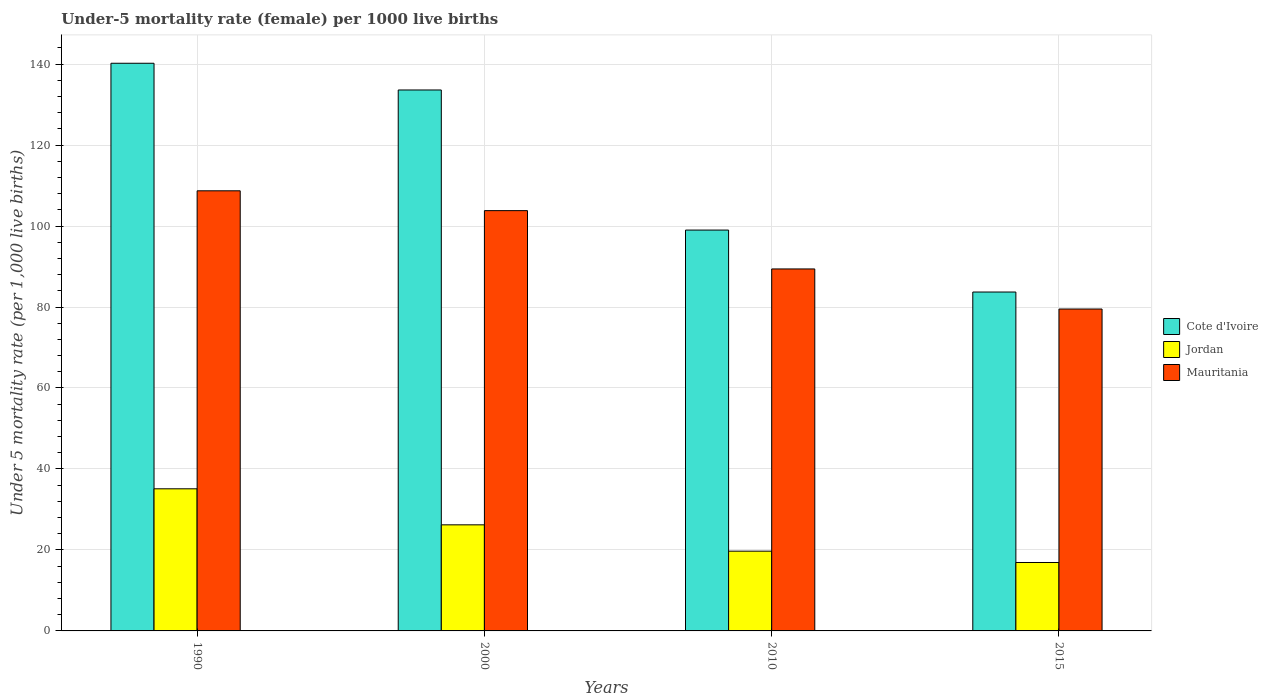How many different coloured bars are there?
Your answer should be very brief. 3. Are the number of bars on each tick of the X-axis equal?
Offer a terse response. Yes. How many bars are there on the 1st tick from the right?
Your answer should be very brief. 3. What is the label of the 1st group of bars from the left?
Make the answer very short. 1990. What is the under-five mortality rate in Cote d'Ivoire in 2010?
Make the answer very short. 99. Across all years, what is the maximum under-five mortality rate in Jordan?
Ensure brevity in your answer.  35.1. Across all years, what is the minimum under-five mortality rate in Mauritania?
Make the answer very short. 79.5. In which year was the under-five mortality rate in Jordan minimum?
Provide a succinct answer. 2015. What is the total under-five mortality rate in Jordan in the graph?
Provide a succinct answer. 97.9. What is the difference between the under-five mortality rate in Cote d'Ivoire in 2000 and that in 2015?
Provide a short and direct response. 49.9. What is the difference between the under-five mortality rate in Cote d'Ivoire in 2000 and the under-five mortality rate in Jordan in 2010?
Offer a terse response. 113.9. What is the average under-five mortality rate in Mauritania per year?
Your response must be concise. 95.35. In the year 2000, what is the difference between the under-five mortality rate in Mauritania and under-five mortality rate in Cote d'Ivoire?
Provide a short and direct response. -29.8. What is the ratio of the under-five mortality rate in Cote d'Ivoire in 2010 to that in 2015?
Ensure brevity in your answer.  1.18. Is the under-five mortality rate in Jordan in 1990 less than that in 2010?
Your answer should be very brief. No. Is the difference between the under-five mortality rate in Mauritania in 2010 and 2015 greater than the difference between the under-five mortality rate in Cote d'Ivoire in 2010 and 2015?
Your response must be concise. No. What is the difference between the highest and the second highest under-five mortality rate in Mauritania?
Offer a terse response. 4.9. What is the difference between the highest and the lowest under-five mortality rate in Mauritania?
Provide a short and direct response. 29.2. What does the 3rd bar from the left in 2015 represents?
Keep it short and to the point. Mauritania. What does the 1st bar from the right in 2010 represents?
Make the answer very short. Mauritania. Is it the case that in every year, the sum of the under-five mortality rate in Mauritania and under-five mortality rate in Jordan is greater than the under-five mortality rate in Cote d'Ivoire?
Provide a short and direct response. No. How many bars are there?
Provide a short and direct response. 12. Are all the bars in the graph horizontal?
Keep it short and to the point. No. How many years are there in the graph?
Your answer should be compact. 4. What is the difference between two consecutive major ticks on the Y-axis?
Provide a short and direct response. 20. Are the values on the major ticks of Y-axis written in scientific E-notation?
Your answer should be compact. No. Where does the legend appear in the graph?
Your answer should be very brief. Center right. How many legend labels are there?
Ensure brevity in your answer.  3. What is the title of the graph?
Provide a succinct answer. Under-5 mortality rate (female) per 1000 live births. What is the label or title of the Y-axis?
Provide a succinct answer. Under 5 mortality rate (per 1,0 live births). What is the Under 5 mortality rate (per 1,000 live births) in Cote d'Ivoire in 1990?
Provide a succinct answer. 140.2. What is the Under 5 mortality rate (per 1,000 live births) in Jordan in 1990?
Keep it short and to the point. 35.1. What is the Under 5 mortality rate (per 1,000 live births) in Mauritania in 1990?
Provide a succinct answer. 108.7. What is the Under 5 mortality rate (per 1,000 live births) in Cote d'Ivoire in 2000?
Ensure brevity in your answer.  133.6. What is the Under 5 mortality rate (per 1,000 live births) of Jordan in 2000?
Make the answer very short. 26.2. What is the Under 5 mortality rate (per 1,000 live births) in Mauritania in 2000?
Your response must be concise. 103.8. What is the Under 5 mortality rate (per 1,000 live births) of Cote d'Ivoire in 2010?
Give a very brief answer. 99. What is the Under 5 mortality rate (per 1,000 live births) in Jordan in 2010?
Your answer should be compact. 19.7. What is the Under 5 mortality rate (per 1,000 live births) in Mauritania in 2010?
Your answer should be compact. 89.4. What is the Under 5 mortality rate (per 1,000 live births) of Cote d'Ivoire in 2015?
Provide a succinct answer. 83.7. What is the Under 5 mortality rate (per 1,000 live births) in Mauritania in 2015?
Provide a short and direct response. 79.5. Across all years, what is the maximum Under 5 mortality rate (per 1,000 live births) in Cote d'Ivoire?
Offer a terse response. 140.2. Across all years, what is the maximum Under 5 mortality rate (per 1,000 live births) of Jordan?
Keep it short and to the point. 35.1. Across all years, what is the maximum Under 5 mortality rate (per 1,000 live births) in Mauritania?
Your answer should be compact. 108.7. Across all years, what is the minimum Under 5 mortality rate (per 1,000 live births) in Cote d'Ivoire?
Provide a short and direct response. 83.7. Across all years, what is the minimum Under 5 mortality rate (per 1,000 live births) in Jordan?
Provide a short and direct response. 16.9. Across all years, what is the minimum Under 5 mortality rate (per 1,000 live births) in Mauritania?
Your answer should be compact. 79.5. What is the total Under 5 mortality rate (per 1,000 live births) of Cote d'Ivoire in the graph?
Provide a short and direct response. 456.5. What is the total Under 5 mortality rate (per 1,000 live births) of Jordan in the graph?
Your answer should be very brief. 97.9. What is the total Under 5 mortality rate (per 1,000 live births) of Mauritania in the graph?
Give a very brief answer. 381.4. What is the difference between the Under 5 mortality rate (per 1,000 live births) in Mauritania in 1990 and that in 2000?
Make the answer very short. 4.9. What is the difference between the Under 5 mortality rate (per 1,000 live births) of Cote d'Ivoire in 1990 and that in 2010?
Keep it short and to the point. 41.2. What is the difference between the Under 5 mortality rate (per 1,000 live births) of Jordan in 1990 and that in 2010?
Your answer should be very brief. 15.4. What is the difference between the Under 5 mortality rate (per 1,000 live births) in Mauritania in 1990 and that in 2010?
Give a very brief answer. 19.3. What is the difference between the Under 5 mortality rate (per 1,000 live births) of Cote d'Ivoire in 1990 and that in 2015?
Make the answer very short. 56.5. What is the difference between the Under 5 mortality rate (per 1,000 live births) of Mauritania in 1990 and that in 2015?
Your answer should be very brief. 29.2. What is the difference between the Under 5 mortality rate (per 1,000 live births) in Cote d'Ivoire in 2000 and that in 2010?
Your answer should be compact. 34.6. What is the difference between the Under 5 mortality rate (per 1,000 live births) in Mauritania in 2000 and that in 2010?
Offer a terse response. 14.4. What is the difference between the Under 5 mortality rate (per 1,000 live births) of Cote d'Ivoire in 2000 and that in 2015?
Keep it short and to the point. 49.9. What is the difference between the Under 5 mortality rate (per 1,000 live births) of Jordan in 2000 and that in 2015?
Offer a terse response. 9.3. What is the difference between the Under 5 mortality rate (per 1,000 live births) of Mauritania in 2000 and that in 2015?
Offer a very short reply. 24.3. What is the difference between the Under 5 mortality rate (per 1,000 live births) in Cote d'Ivoire in 2010 and that in 2015?
Ensure brevity in your answer.  15.3. What is the difference between the Under 5 mortality rate (per 1,000 live births) in Jordan in 2010 and that in 2015?
Keep it short and to the point. 2.8. What is the difference between the Under 5 mortality rate (per 1,000 live births) of Cote d'Ivoire in 1990 and the Under 5 mortality rate (per 1,000 live births) of Jordan in 2000?
Offer a terse response. 114. What is the difference between the Under 5 mortality rate (per 1,000 live births) of Cote d'Ivoire in 1990 and the Under 5 mortality rate (per 1,000 live births) of Mauritania in 2000?
Your response must be concise. 36.4. What is the difference between the Under 5 mortality rate (per 1,000 live births) in Jordan in 1990 and the Under 5 mortality rate (per 1,000 live births) in Mauritania in 2000?
Offer a very short reply. -68.7. What is the difference between the Under 5 mortality rate (per 1,000 live births) of Cote d'Ivoire in 1990 and the Under 5 mortality rate (per 1,000 live births) of Jordan in 2010?
Provide a succinct answer. 120.5. What is the difference between the Under 5 mortality rate (per 1,000 live births) in Cote d'Ivoire in 1990 and the Under 5 mortality rate (per 1,000 live births) in Mauritania in 2010?
Offer a terse response. 50.8. What is the difference between the Under 5 mortality rate (per 1,000 live births) of Jordan in 1990 and the Under 5 mortality rate (per 1,000 live births) of Mauritania in 2010?
Offer a terse response. -54.3. What is the difference between the Under 5 mortality rate (per 1,000 live births) of Cote d'Ivoire in 1990 and the Under 5 mortality rate (per 1,000 live births) of Jordan in 2015?
Provide a succinct answer. 123.3. What is the difference between the Under 5 mortality rate (per 1,000 live births) in Cote d'Ivoire in 1990 and the Under 5 mortality rate (per 1,000 live births) in Mauritania in 2015?
Ensure brevity in your answer.  60.7. What is the difference between the Under 5 mortality rate (per 1,000 live births) of Jordan in 1990 and the Under 5 mortality rate (per 1,000 live births) of Mauritania in 2015?
Make the answer very short. -44.4. What is the difference between the Under 5 mortality rate (per 1,000 live births) in Cote d'Ivoire in 2000 and the Under 5 mortality rate (per 1,000 live births) in Jordan in 2010?
Provide a succinct answer. 113.9. What is the difference between the Under 5 mortality rate (per 1,000 live births) in Cote d'Ivoire in 2000 and the Under 5 mortality rate (per 1,000 live births) in Mauritania in 2010?
Offer a terse response. 44.2. What is the difference between the Under 5 mortality rate (per 1,000 live births) of Jordan in 2000 and the Under 5 mortality rate (per 1,000 live births) of Mauritania in 2010?
Keep it short and to the point. -63.2. What is the difference between the Under 5 mortality rate (per 1,000 live births) in Cote d'Ivoire in 2000 and the Under 5 mortality rate (per 1,000 live births) in Jordan in 2015?
Ensure brevity in your answer.  116.7. What is the difference between the Under 5 mortality rate (per 1,000 live births) of Cote d'Ivoire in 2000 and the Under 5 mortality rate (per 1,000 live births) of Mauritania in 2015?
Your answer should be compact. 54.1. What is the difference between the Under 5 mortality rate (per 1,000 live births) in Jordan in 2000 and the Under 5 mortality rate (per 1,000 live births) in Mauritania in 2015?
Offer a terse response. -53.3. What is the difference between the Under 5 mortality rate (per 1,000 live births) of Cote d'Ivoire in 2010 and the Under 5 mortality rate (per 1,000 live births) of Jordan in 2015?
Offer a very short reply. 82.1. What is the difference between the Under 5 mortality rate (per 1,000 live births) in Cote d'Ivoire in 2010 and the Under 5 mortality rate (per 1,000 live births) in Mauritania in 2015?
Ensure brevity in your answer.  19.5. What is the difference between the Under 5 mortality rate (per 1,000 live births) in Jordan in 2010 and the Under 5 mortality rate (per 1,000 live births) in Mauritania in 2015?
Your response must be concise. -59.8. What is the average Under 5 mortality rate (per 1,000 live births) in Cote d'Ivoire per year?
Offer a terse response. 114.12. What is the average Under 5 mortality rate (per 1,000 live births) of Jordan per year?
Offer a very short reply. 24.48. What is the average Under 5 mortality rate (per 1,000 live births) in Mauritania per year?
Your answer should be very brief. 95.35. In the year 1990, what is the difference between the Under 5 mortality rate (per 1,000 live births) in Cote d'Ivoire and Under 5 mortality rate (per 1,000 live births) in Jordan?
Give a very brief answer. 105.1. In the year 1990, what is the difference between the Under 5 mortality rate (per 1,000 live births) in Cote d'Ivoire and Under 5 mortality rate (per 1,000 live births) in Mauritania?
Offer a very short reply. 31.5. In the year 1990, what is the difference between the Under 5 mortality rate (per 1,000 live births) of Jordan and Under 5 mortality rate (per 1,000 live births) of Mauritania?
Your response must be concise. -73.6. In the year 2000, what is the difference between the Under 5 mortality rate (per 1,000 live births) in Cote d'Ivoire and Under 5 mortality rate (per 1,000 live births) in Jordan?
Give a very brief answer. 107.4. In the year 2000, what is the difference between the Under 5 mortality rate (per 1,000 live births) in Cote d'Ivoire and Under 5 mortality rate (per 1,000 live births) in Mauritania?
Your response must be concise. 29.8. In the year 2000, what is the difference between the Under 5 mortality rate (per 1,000 live births) of Jordan and Under 5 mortality rate (per 1,000 live births) of Mauritania?
Provide a succinct answer. -77.6. In the year 2010, what is the difference between the Under 5 mortality rate (per 1,000 live births) in Cote d'Ivoire and Under 5 mortality rate (per 1,000 live births) in Jordan?
Offer a terse response. 79.3. In the year 2010, what is the difference between the Under 5 mortality rate (per 1,000 live births) in Jordan and Under 5 mortality rate (per 1,000 live births) in Mauritania?
Offer a terse response. -69.7. In the year 2015, what is the difference between the Under 5 mortality rate (per 1,000 live births) of Cote d'Ivoire and Under 5 mortality rate (per 1,000 live births) of Jordan?
Keep it short and to the point. 66.8. In the year 2015, what is the difference between the Under 5 mortality rate (per 1,000 live births) in Jordan and Under 5 mortality rate (per 1,000 live births) in Mauritania?
Make the answer very short. -62.6. What is the ratio of the Under 5 mortality rate (per 1,000 live births) in Cote d'Ivoire in 1990 to that in 2000?
Offer a terse response. 1.05. What is the ratio of the Under 5 mortality rate (per 1,000 live births) of Jordan in 1990 to that in 2000?
Provide a short and direct response. 1.34. What is the ratio of the Under 5 mortality rate (per 1,000 live births) in Mauritania in 1990 to that in 2000?
Make the answer very short. 1.05. What is the ratio of the Under 5 mortality rate (per 1,000 live births) of Cote d'Ivoire in 1990 to that in 2010?
Keep it short and to the point. 1.42. What is the ratio of the Under 5 mortality rate (per 1,000 live births) of Jordan in 1990 to that in 2010?
Your response must be concise. 1.78. What is the ratio of the Under 5 mortality rate (per 1,000 live births) in Mauritania in 1990 to that in 2010?
Your response must be concise. 1.22. What is the ratio of the Under 5 mortality rate (per 1,000 live births) of Cote d'Ivoire in 1990 to that in 2015?
Your answer should be very brief. 1.68. What is the ratio of the Under 5 mortality rate (per 1,000 live births) of Jordan in 1990 to that in 2015?
Your answer should be very brief. 2.08. What is the ratio of the Under 5 mortality rate (per 1,000 live births) in Mauritania in 1990 to that in 2015?
Offer a terse response. 1.37. What is the ratio of the Under 5 mortality rate (per 1,000 live births) in Cote d'Ivoire in 2000 to that in 2010?
Ensure brevity in your answer.  1.35. What is the ratio of the Under 5 mortality rate (per 1,000 live births) of Jordan in 2000 to that in 2010?
Your response must be concise. 1.33. What is the ratio of the Under 5 mortality rate (per 1,000 live births) in Mauritania in 2000 to that in 2010?
Keep it short and to the point. 1.16. What is the ratio of the Under 5 mortality rate (per 1,000 live births) in Cote d'Ivoire in 2000 to that in 2015?
Make the answer very short. 1.6. What is the ratio of the Under 5 mortality rate (per 1,000 live births) of Jordan in 2000 to that in 2015?
Keep it short and to the point. 1.55. What is the ratio of the Under 5 mortality rate (per 1,000 live births) in Mauritania in 2000 to that in 2015?
Provide a short and direct response. 1.31. What is the ratio of the Under 5 mortality rate (per 1,000 live births) of Cote d'Ivoire in 2010 to that in 2015?
Your answer should be very brief. 1.18. What is the ratio of the Under 5 mortality rate (per 1,000 live births) of Jordan in 2010 to that in 2015?
Provide a succinct answer. 1.17. What is the ratio of the Under 5 mortality rate (per 1,000 live births) of Mauritania in 2010 to that in 2015?
Your response must be concise. 1.12. What is the difference between the highest and the second highest Under 5 mortality rate (per 1,000 live births) of Jordan?
Your response must be concise. 8.9. What is the difference between the highest and the second highest Under 5 mortality rate (per 1,000 live births) of Mauritania?
Give a very brief answer. 4.9. What is the difference between the highest and the lowest Under 5 mortality rate (per 1,000 live births) in Cote d'Ivoire?
Your answer should be very brief. 56.5. What is the difference between the highest and the lowest Under 5 mortality rate (per 1,000 live births) in Mauritania?
Provide a succinct answer. 29.2. 